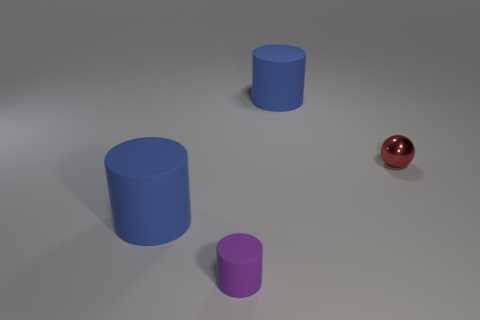Add 4 small cyan matte balls. How many objects exist? 8 Subtract all cylinders. How many objects are left? 1 Subtract 0 blue blocks. How many objects are left? 4 Subtract all tiny red spheres. Subtract all blue rubber objects. How many objects are left? 1 Add 2 shiny things. How many shiny things are left? 3 Add 3 cylinders. How many cylinders exist? 6 